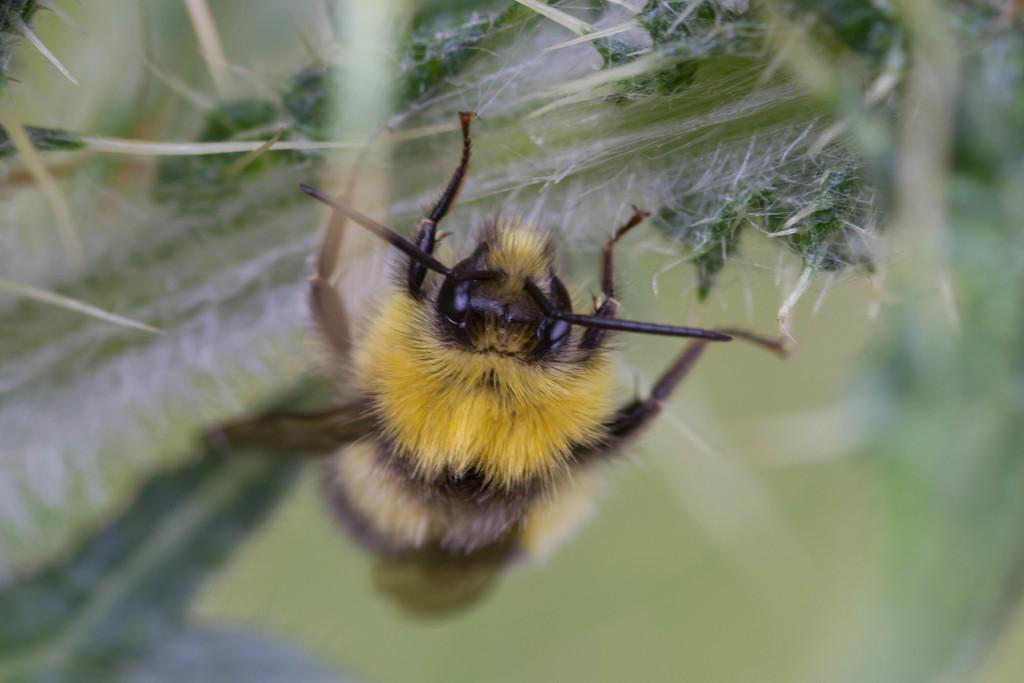What type of creature is in the image? There is an insect in the image. What colors can be seen on the insect? The insect has black, yellow, and cream coloring. Where is the insect located in the image? The insect is on a plant. What colors can be seen on the plant? The plant has green and white coloring. How would you describe the background of the image? The background of the image is blurry. What direction is the bird flying in the image? There is no bird present in the image; it features an insect on a plant. Who is the manager of the insect in the image? Insects do not have managers, as they are not human-controlled or managed creatures. 